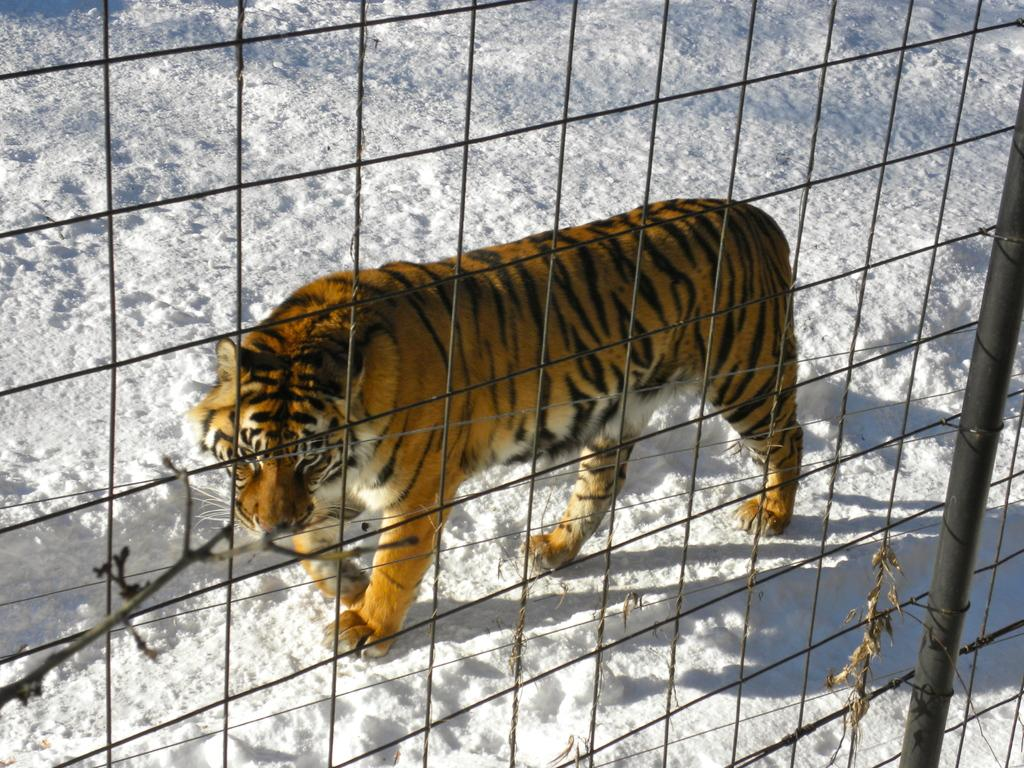What animal is in the image? There is a tiger in the image. Where is the tiger located? The tiger is in a fence. What is the weather or season suggested by the snow in the image? The snow visible in the background and bottom of the image suggests a cold or wintery environment. What type of vegetation can be seen in the image? Branches of a tree are present in the image. What structures are visible in the foreground of the image? Poles are visible in the foreground of the image. What color is the sister's orange in the image? There is no sister or orange present in the image. How much does the tiger weigh on a scale in the image? There is no scale present in the image, so it is not possible to determine the tiger's weight. 